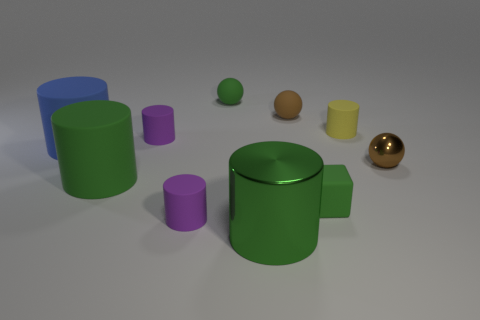Subtract all small rubber balls. How many balls are left? 1 Subtract 1 cylinders. How many cylinders are left? 5 Subtract all gray blocks. How many blue cylinders are left? 1 Subtract all green balls. How many balls are left? 2 Subtract all cubes. How many objects are left? 9 Subtract all large blocks. Subtract all small green matte cubes. How many objects are left? 9 Add 8 tiny brown matte spheres. How many tiny brown matte spheres are left? 9 Add 1 tiny cubes. How many tiny cubes exist? 2 Subtract 0 cyan balls. How many objects are left? 10 Subtract all blue cylinders. Subtract all yellow cubes. How many cylinders are left? 5 